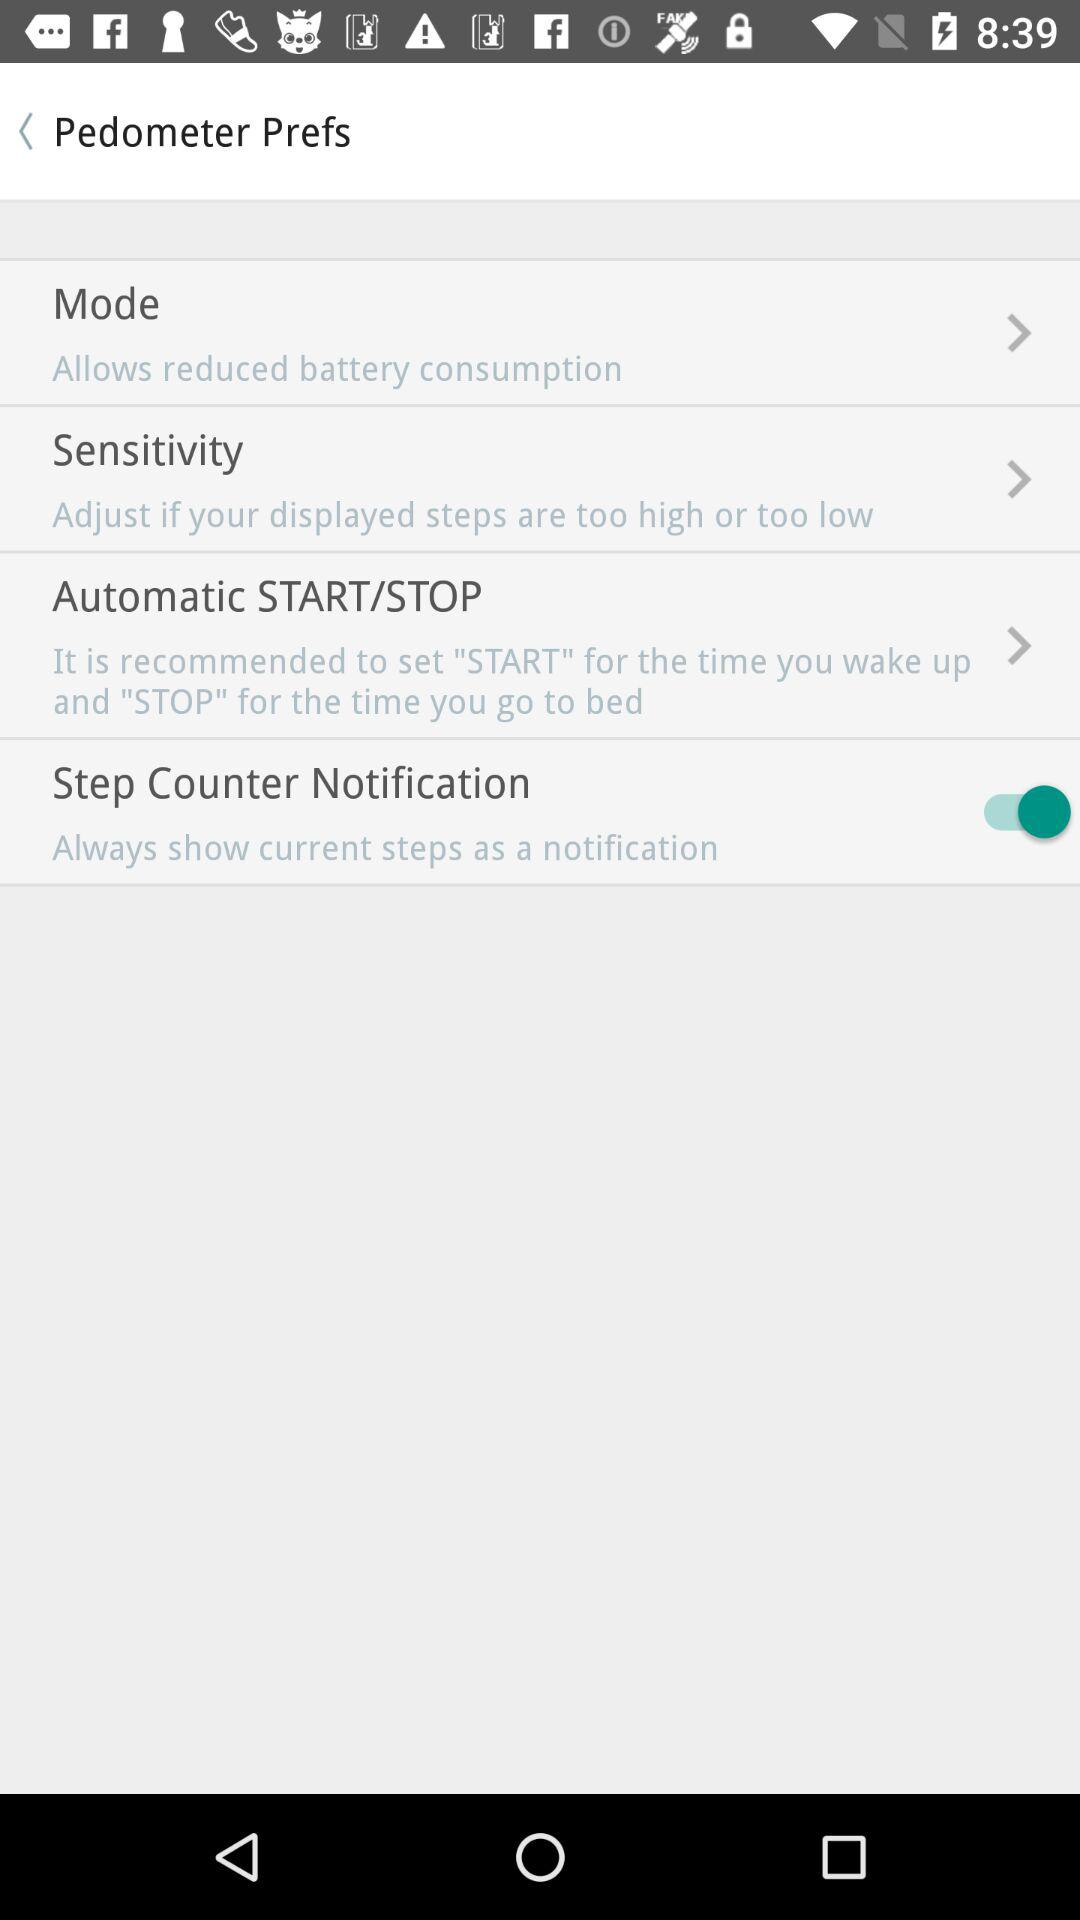Which button should you press when you wake up? You should press the "START" button when you wake up. 